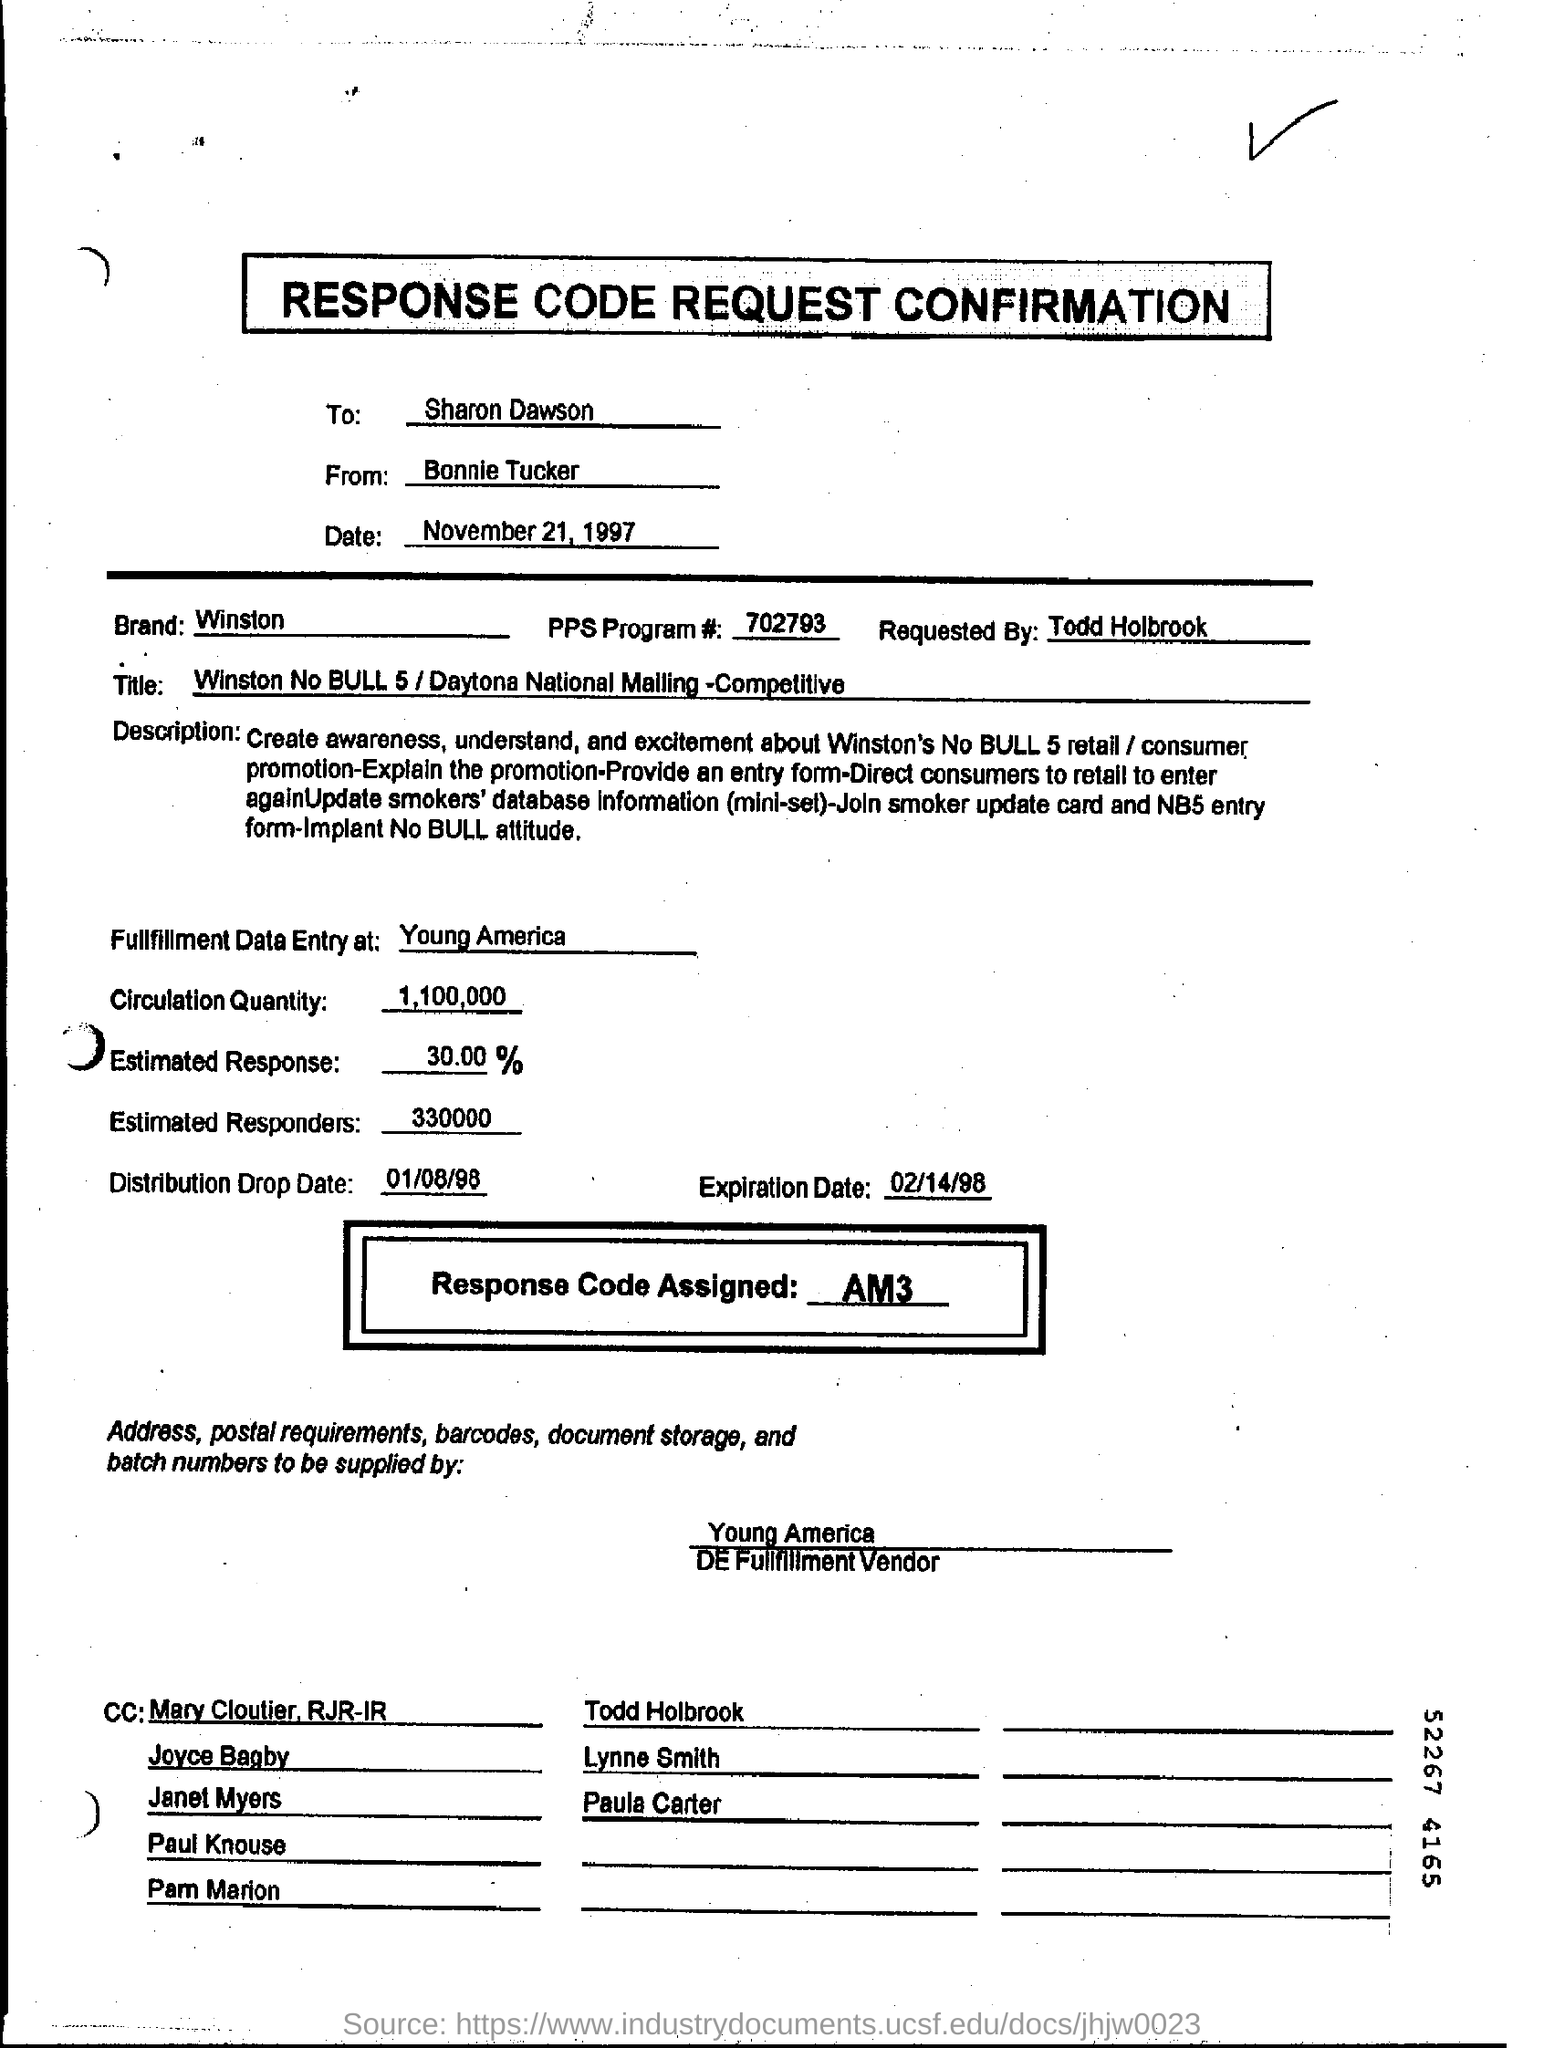Who is this request to?
Your answer should be very brief. Sharon Dawson. Who is this request from?
Make the answer very short. Bonnie Tucker. What is the date of request?
Offer a very short reply. November 21, 1997. What is the Brand mentioned?
Ensure brevity in your answer.  WINSTON. 